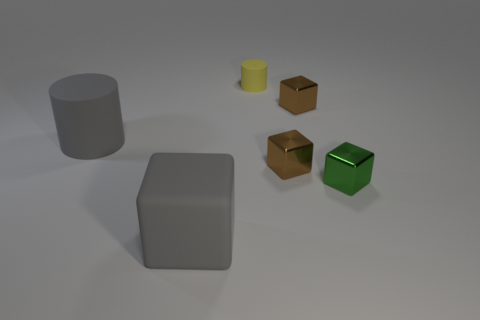Does the big cylinder have the same color as the big cube?
Offer a terse response. Yes. What is the cube behind the large cylinder made of?
Offer a very short reply. Metal. The object that is the same color as the large block is what shape?
Give a very brief answer. Cylinder. There is a tiny green object that is right of the thing that is in front of the small green block; what is it made of?
Your answer should be compact. Metal. Is the color of the matte cylinder to the left of the rubber cube the same as the block to the left of the tiny matte cylinder?
Ensure brevity in your answer.  Yes. The matte cylinder that is the same size as the gray cube is what color?
Make the answer very short. Gray. Are there any big rubber objects that have the same color as the matte block?
Ensure brevity in your answer.  Yes. Is the size of the block that is in front of the green metallic block the same as the tiny matte cylinder?
Ensure brevity in your answer.  No. Are there the same number of big gray things that are in front of the gray cube and balls?
Provide a succinct answer. Yes. What number of things are large gray matte things that are behind the large rubber cube or large gray matte blocks?
Give a very brief answer. 2. 